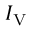Convert formula to latex. <formula><loc_0><loc_0><loc_500><loc_500>I _ { V }</formula> 